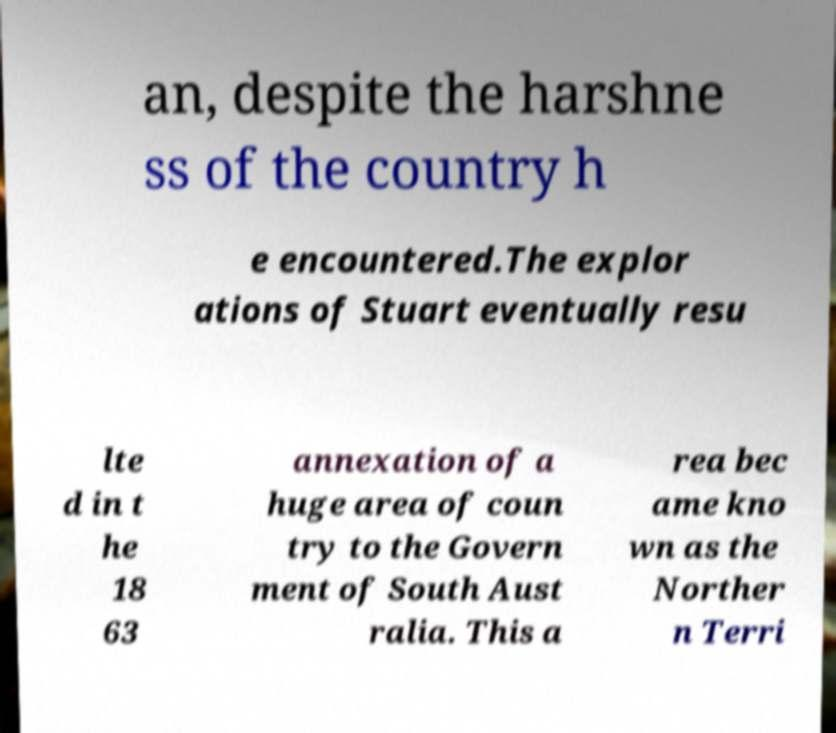Could you assist in decoding the text presented in this image and type it out clearly? an, despite the harshne ss of the country h e encountered.The explor ations of Stuart eventually resu lte d in t he 18 63 annexation of a huge area of coun try to the Govern ment of South Aust ralia. This a rea bec ame kno wn as the Norther n Terri 